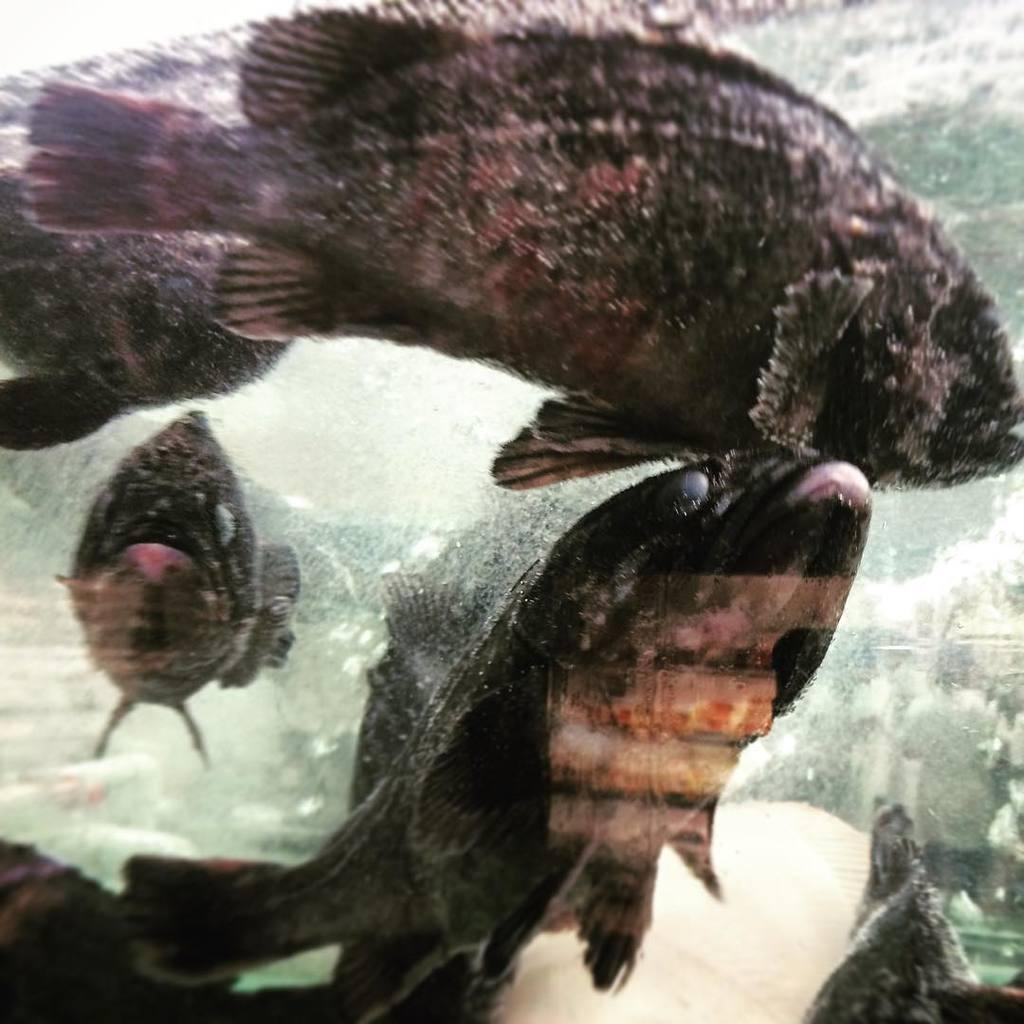What type of animals can be seen in the image? There are fishes in the image. What is the primary element in which the fishes are situated? There is water visible in the image, and the fishes are in the water. What type of note can be seen attached to the leg of the fish in the image? There is no note or leg present in the image, as it features fishes in water. 